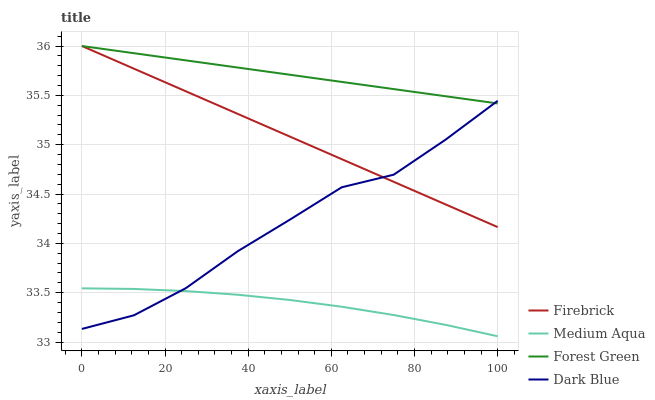Does Medium Aqua have the minimum area under the curve?
Answer yes or no. Yes. Does Forest Green have the maximum area under the curve?
Answer yes or no. Yes. Does Firebrick have the minimum area under the curve?
Answer yes or no. No. Does Firebrick have the maximum area under the curve?
Answer yes or no. No. Is Firebrick the smoothest?
Answer yes or no. Yes. Is Dark Blue the roughest?
Answer yes or no. Yes. Is Medium Aqua the smoothest?
Answer yes or no. No. Is Medium Aqua the roughest?
Answer yes or no. No. Does Medium Aqua have the lowest value?
Answer yes or no. Yes. Does Firebrick have the lowest value?
Answer yes or no. No. Does Forest Green have the highest value?
Answer yes or no. Yes. Does Medium Aqua have the highest value?
Answer yes or no. No. Is Medium Aqua less than Forest Green?
Answer yes or no. Yes. Is Firebrick greater than Medium Aqua?
Answer yes or no. Yes. Does Forest Green intersect Firebrick?
Answer yes or no. Yes. Is Forest Green less than Firebrick?
Answer yes or no. No. Is Forest Green greater than Firebrick?
Answer yes or no. No. Does Medium Aqua intersect Forest Green?
Answer yes or no. No. 